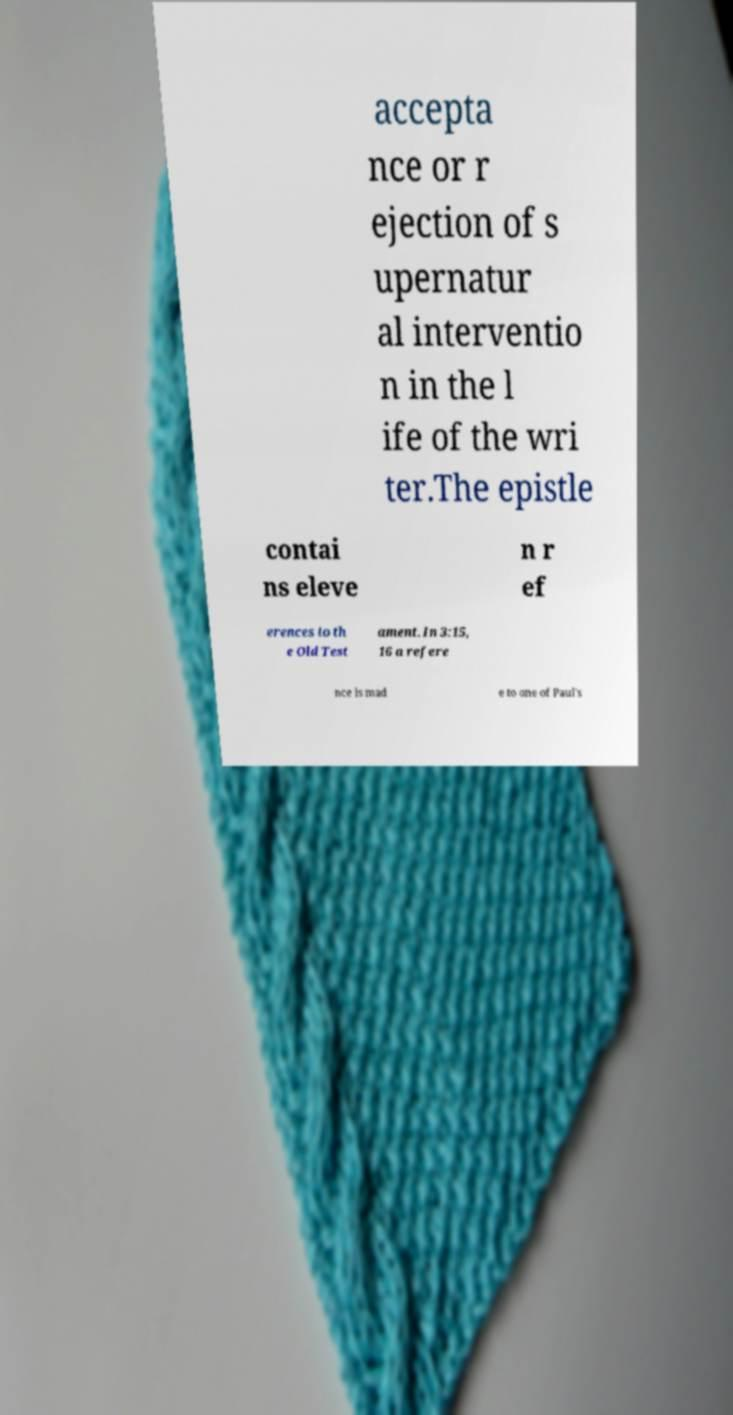Could you extract and type out the text from this image? accepta nce or r ejection of s upernatur al interventio n in the l ife of the wri ter.The epistle contai ns eleve n r ef erences to th e Old Test ament. In 3:15, 16 a refere nce is mad e to one of Paul's 